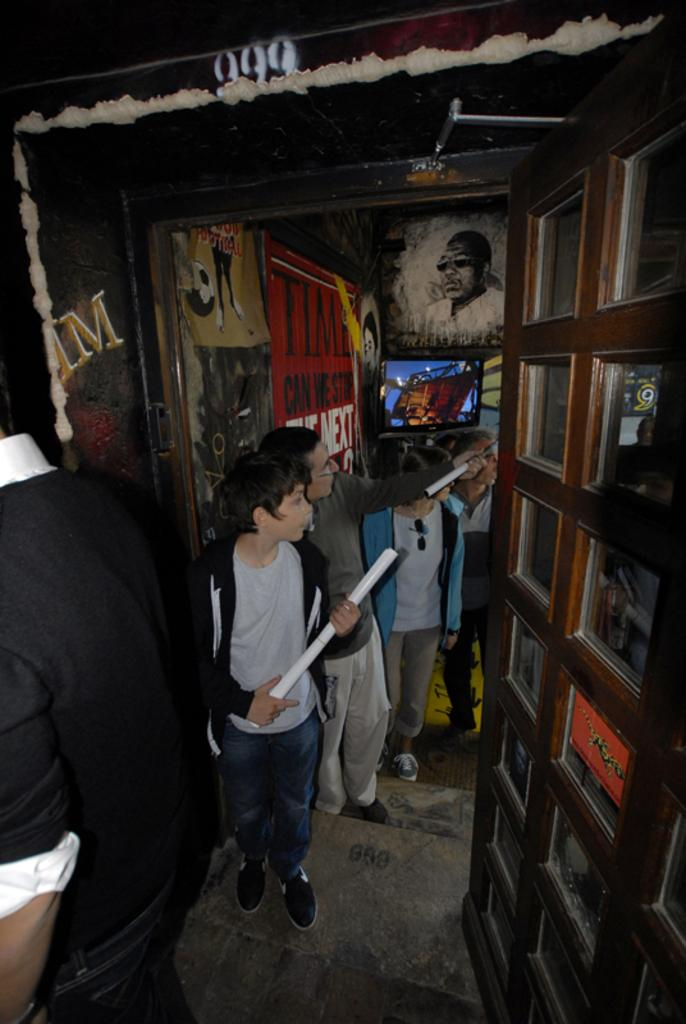How many people are in the image? There are persons in the image, but the exact number cannot be determined from the provided facts. What can be seen in the background of the image? There are posters in the background of the image. What time is displayed on the hour in the image? There is no hour or clock present in the image, so it is not possible to determine the time. 